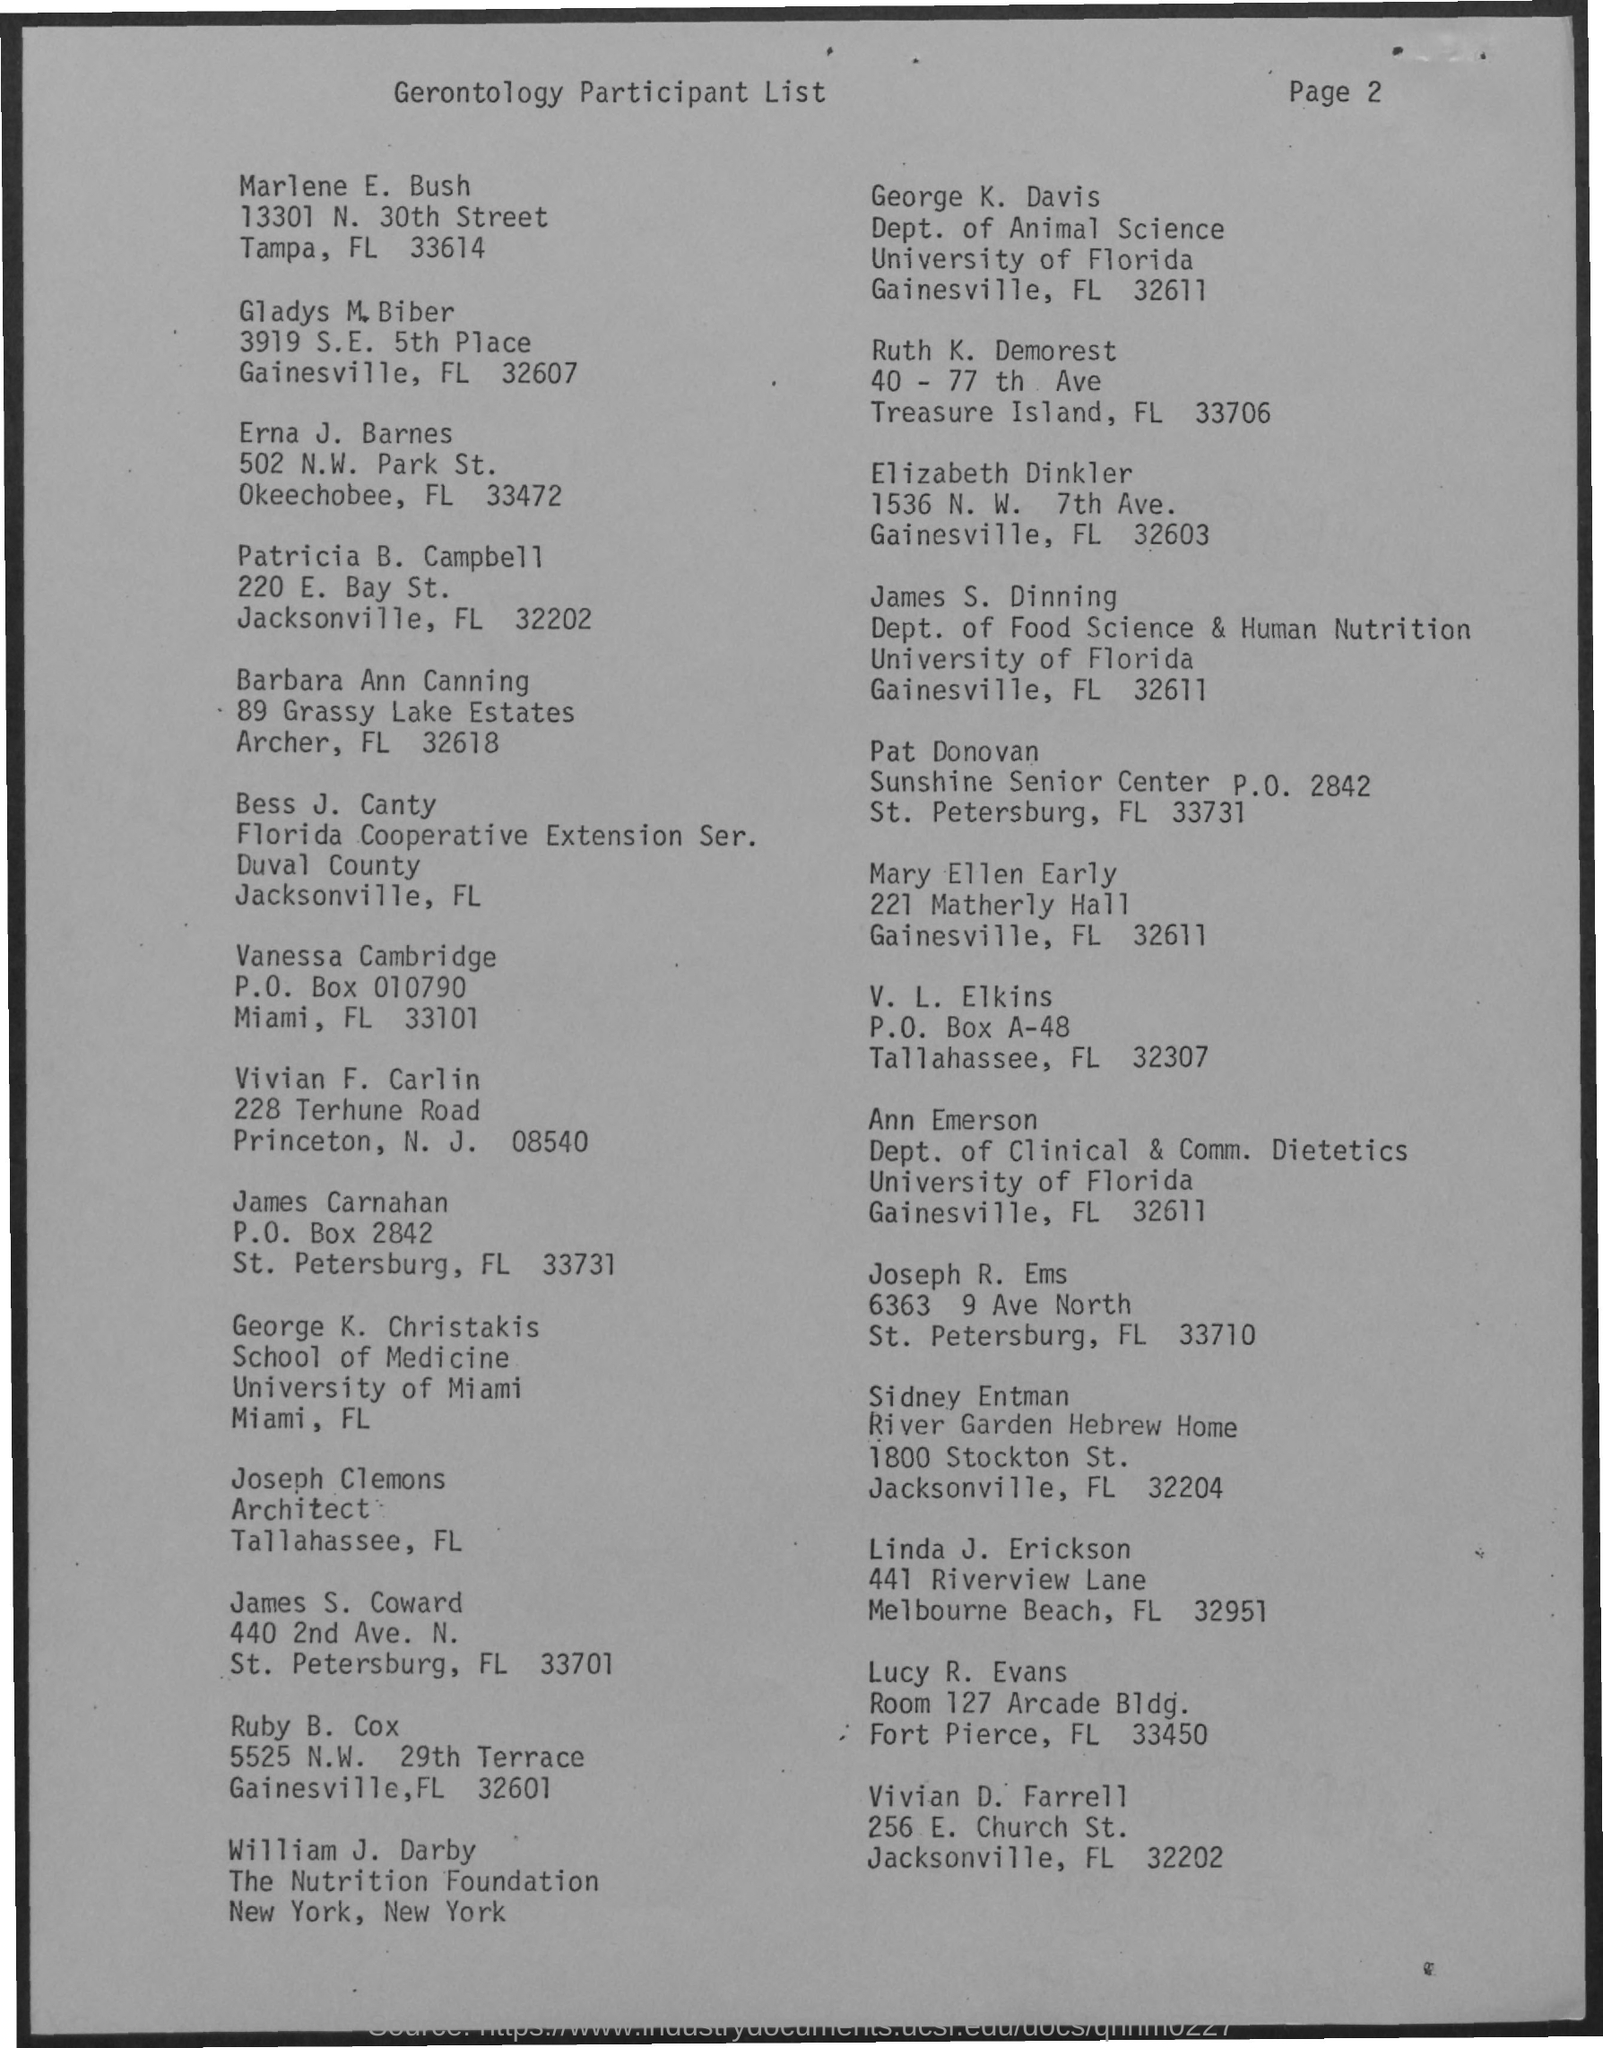What is the title of the document?
Keep it short and to the point. Gerontology Participant List. George K. Christakis is from which university?
Offer a very short reply. University of Miami. What is the designation of Joseph Clemons?
Ensure brevity in your answer.  Architect. James S. Dinning belongs to which department?
Ensure brevity in your answer.  Dept. of Food Science & Human Nutrition. What is the Page Number?
Provide a short and direct response. Page 2. 